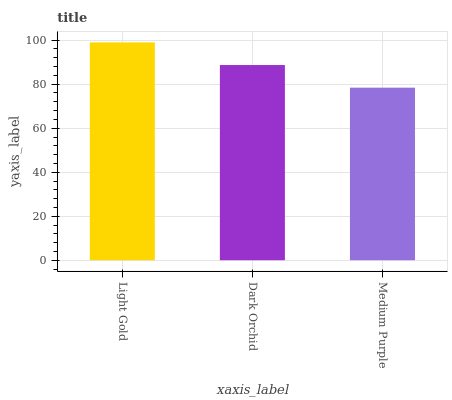Is Medium Purple the minimum?
Answer yes or no. Yes. Is Light Gold the maximum?
Answer yes or no. Yes. Is Dark Orchid the minimum?
Answer yes or no. No. Is Dark Orchid the maximum?
Answer yes or no. No. Is Light Gold greater than Dark Orchid?
Answer yes or no. Yes. Is Dark Orchid less than Light Gold?
Answer yes or no. Yes. Is Dark Orchid greater than Light Gold?
Answer yes or no. No. Is Light Gold less than Dark Orchid?
Answer yes or no. No. Is Dark Orchid the high median?
Answer yes or no. Yes. Is Dark Orchid the low median?
Answer yes or no. Yes. Is Medium Purple the high median?
Answer yes or no. No. Is Light Gold the low median?
Answer yes or no. No. 